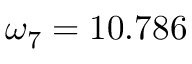<formula> <loc_0><loc_0><loc_500><loc_500>\omega _ { 7 } = 1 0 . 7 8 6</formula> 